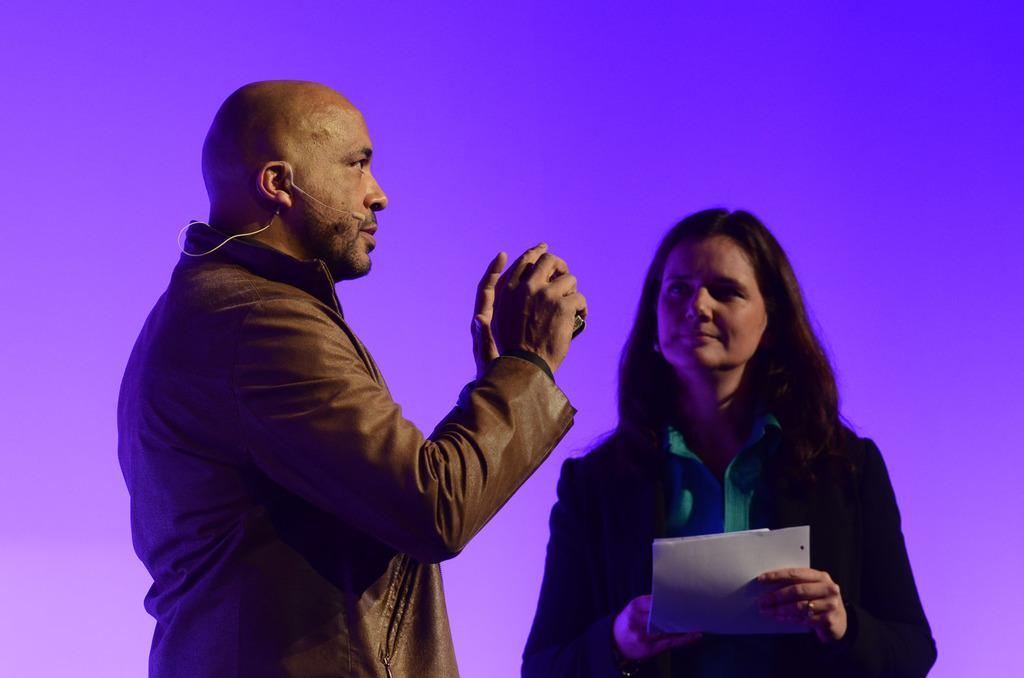How many people are present in the image? There are two people, a man and a woman, present in the image. What is the woman holding in the image? The woman is holding a paper. What object is used for amplifying sound in the image? There is a microphone in the image. What type of yam is the woman holding in the image? There is no yam present in the image; the woman is holding a paper. How many sisters are visible in the image? There is no mention of sisters in the image, only a man and a woman. 